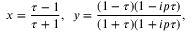Convert formula to latex. <formula><loc_0><loc_0><loc_500><loc_500>x = \frac { \tau - 1 } { \tau + 1 } , \, y = \frac { ( 1 - \tau ) ( 1 - i p \tau ) } { ( 1 + \tau ) ( 1 + i p \tau ) } ,</formula> 